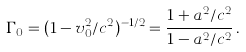Convert formula to latex. <formula><loc_0><loc_0><loc_500><loc_500>\Gamma _ { 0 } = ( 1 - v _ { 0 } ^ { 2 } / c ^ { 2 } ) ^ { - 1 / 2 } = \frac { 1 + a ^ { 2 } / c ^ { 2 } } { 1 - a ^ { 2 } / c ^ { 2 } } \, .</formula> 